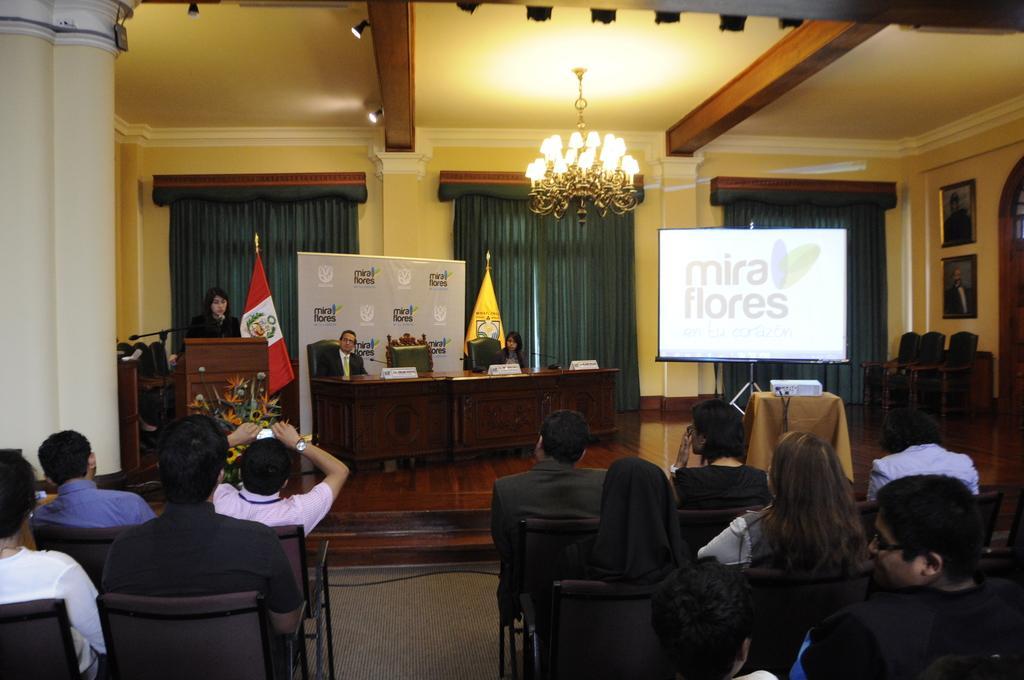Please provide a concise description of this image. At the bottom, there are group of people sitting in the chair. In the middle, there are two person sitting on the chair in front of the table on which name plate is kept. In the right middle, a screen is there of white in color. In the middle both side, a curtain is visible of green in color. A roof top is yellow in color on which chandelier is hanged. The wall is white in color. In the left middle, a woman is standing and speaking in front of the mike in front of the standing table. Behind that there is a flag. This image is taken inside a hall. 